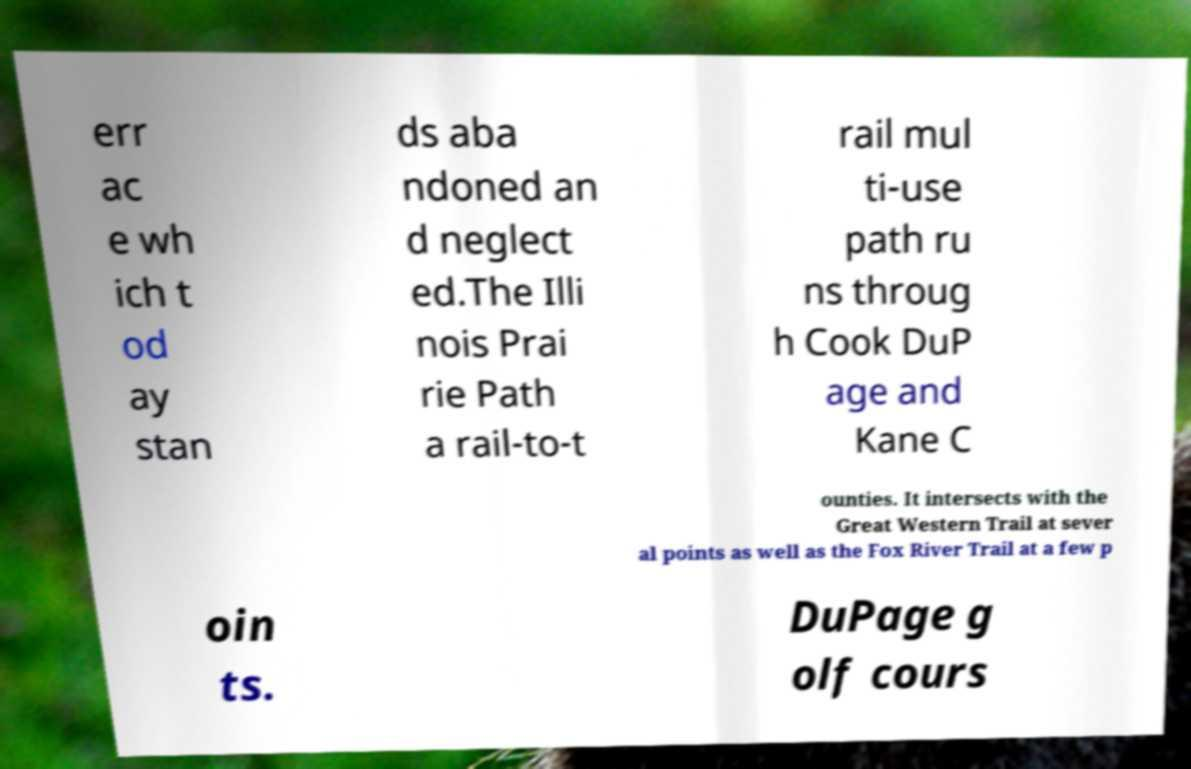Can you read and provide the text displayed in the image?This photo seems to have some interesting text. Can you extract and type it out for me? err ac e wh ich t od ay stan ds aba ndoned an d neglect ed.The Illi nois Prai rie Path a rail-to-t rail mul ti-use path ru ns throug h Cook DuP age and Kane C ounties. It intersects with the Great Western Trail at sever al points as well as the Fox River Trail at a few p oin ts. DuPage g olf cours 